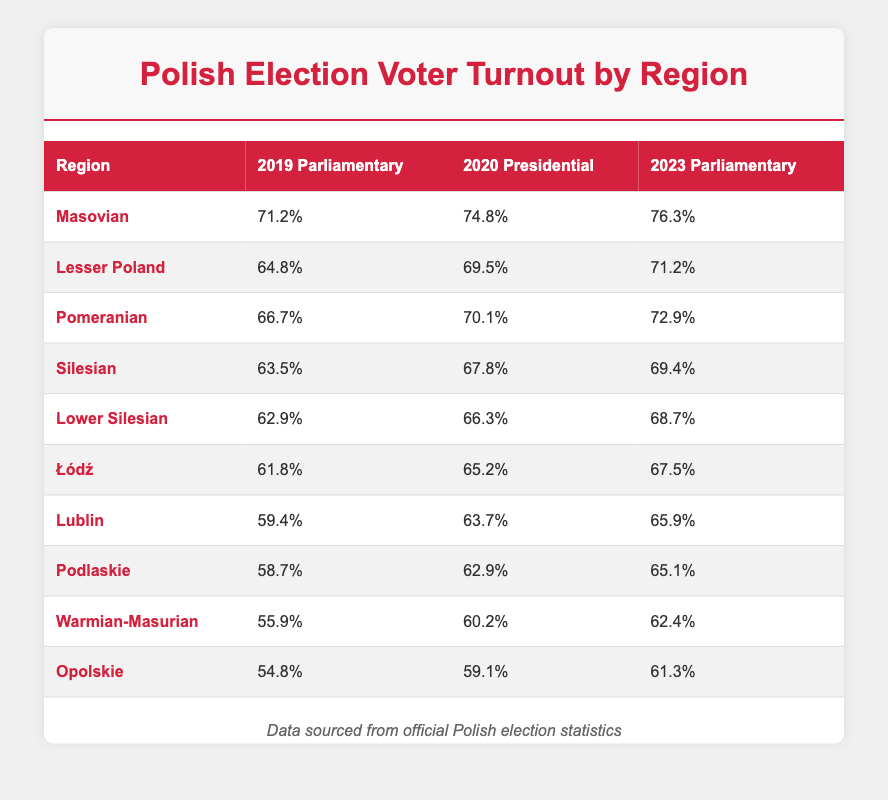What was the voter turnout in the Masovian region for the 2020 Presidential elections? The table shows that the voter turnout for the Masovian region in the 2020 Presidential elections was 74.8%.
Answer: 74.8% Which region had the lowest voter turnout in the 2019 Parliamentary elections? The table indicates that the region with the lowest voter turnout in the 2019 Parliamentary elections was Opolskie, with a turnout of 54.8%.
Answer: Opolskie What is the difference in voter turnout between the 2020 Presidential elections and the 2023 Parliamentary elections for Pomeranian? The table shows the turnout for Pomeranian in 2020 was 70.1% and in 2023 was 72.9%. The difference is 72.9% - 70.1% = 2.8%.
Answer: 2.8% Did voter turnout increase for all regions from the 2019 Parliamentary elections to the 2023 Parliamentary elections? Examining the table, it's clear that all regions show an increase in voter turnout from 2019 to 2023. For example, the Masovian region increased from 71.2% to 76.3%.
Answer: Yes What is the average voter turnout for the 2020 Presidential elections across all listed regions? To find the average, add up the turnouts: 74.8% + 69.5% + 70.1% + 67.8% + 66.3% + 65.2% + 63.7% + 62.9% + 60.2% + 59.1% =  669.7%. There are 10 regions, so the average is 669.7% / 10 = 66.97%.
Answer: 66.97% 